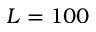<formula> <loc_0><loc_0><loc_500><loc_500>L = 1 0 0</formula> 